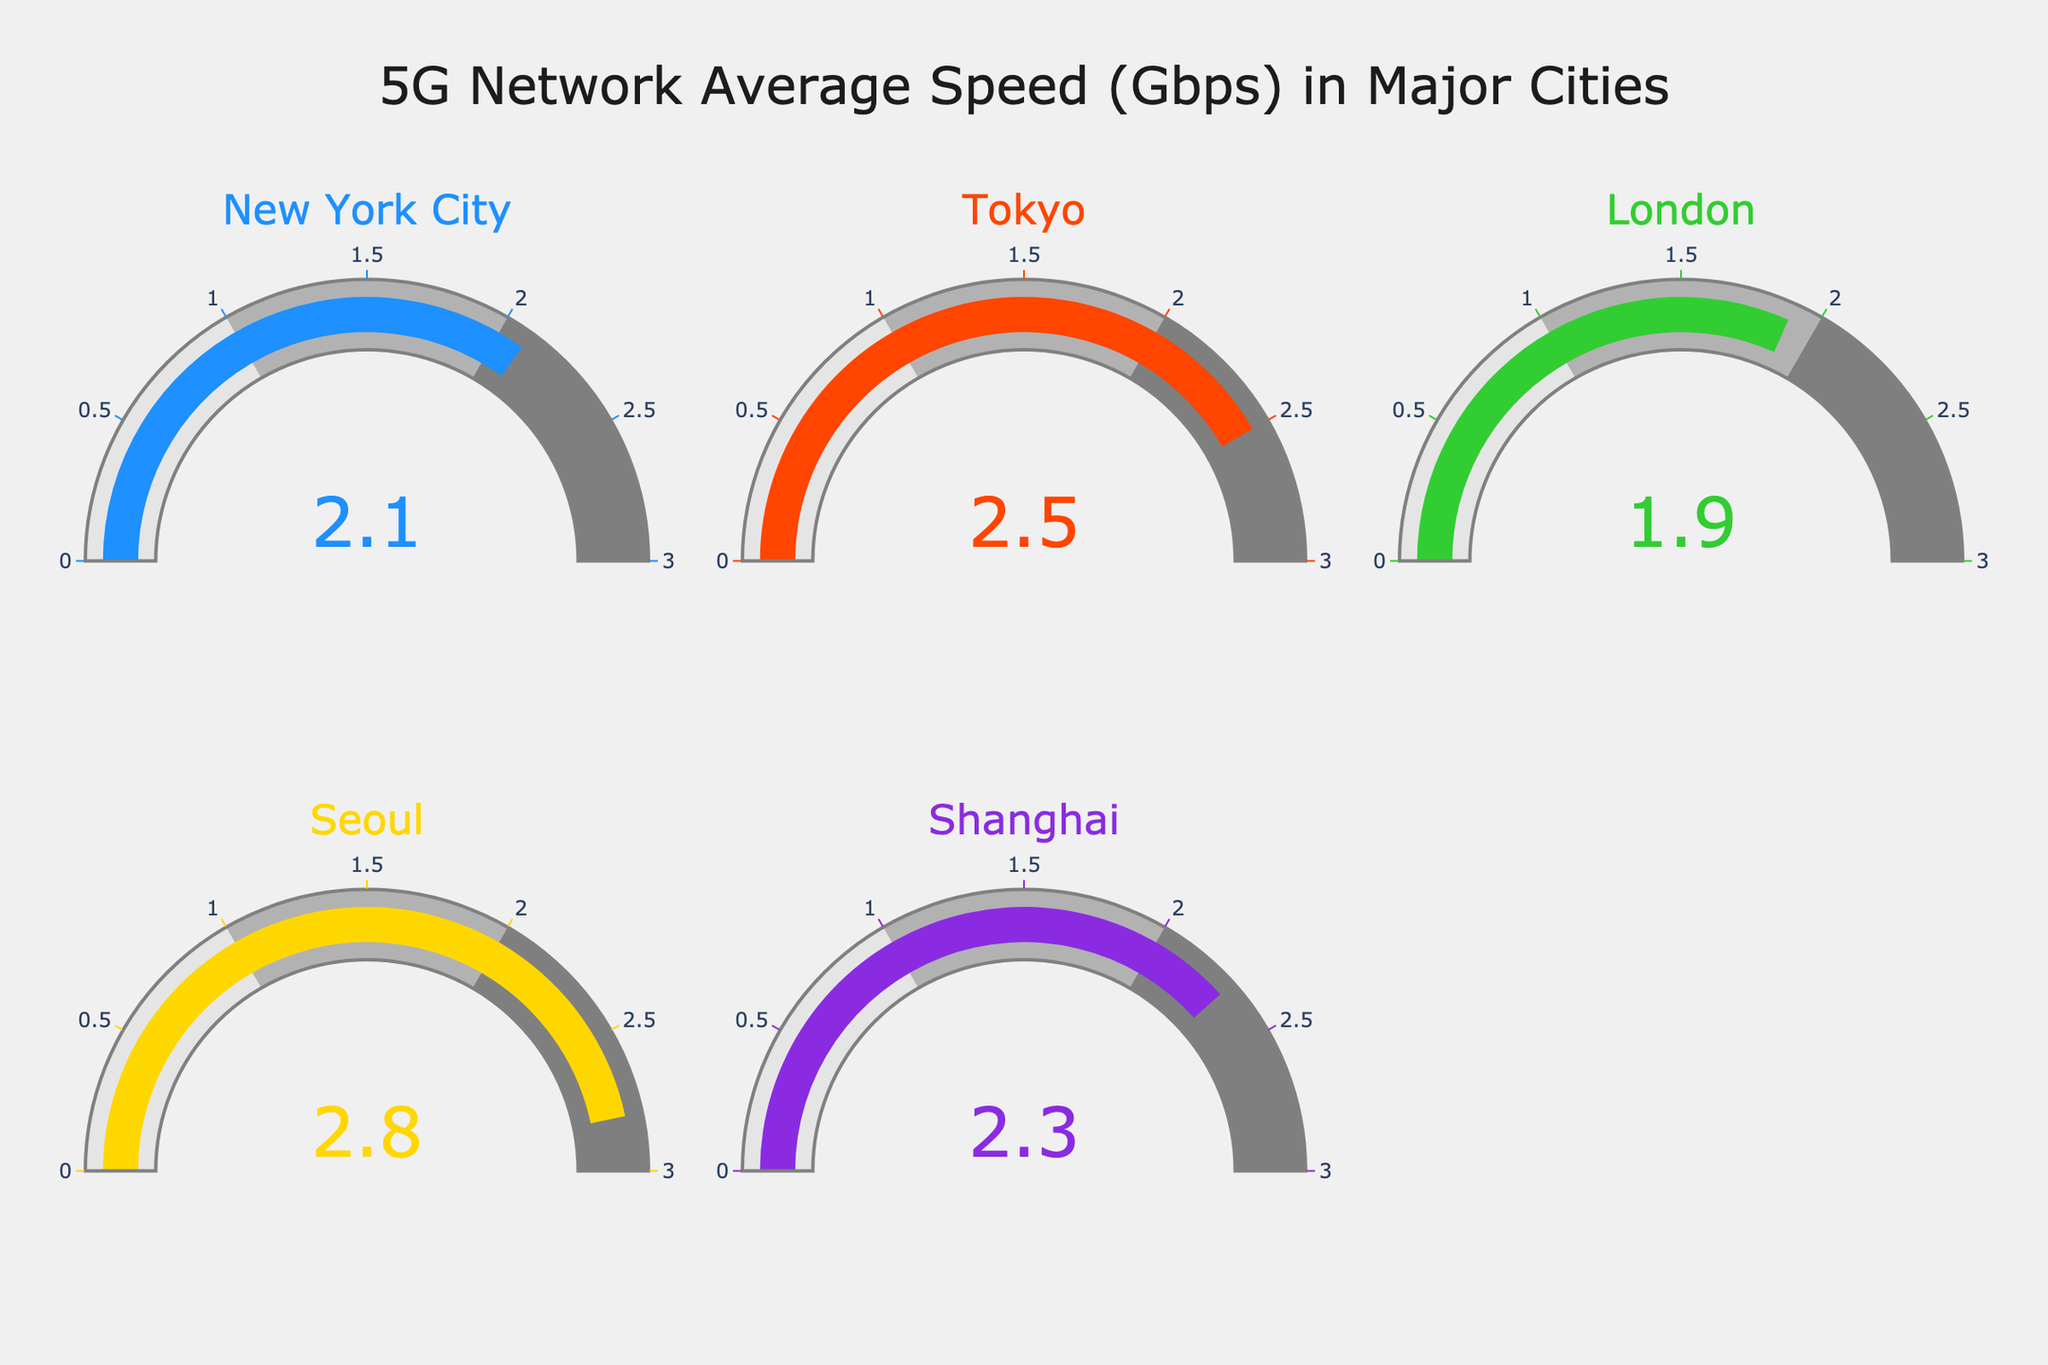which city has the highest average 5G network speed? By examining the gauge charts, we notice each city's average speed. Seoul has the highest speed of 2.8 Gbps.
Answer: Seoul which city has the lowest average 5G network speed? By comparing the gauge charts, we observe that London has the lowest speed at 1.9 Gbps.
Answer: London What is the range of average 5G network speeds displayed in the charts? The highest speed is 2.8 Gbps (Seoul) and the lowest is 1.9 Gbps (London). The range is 2.8 - 1.9 = 0.9 Gbps.
Answer: 0.9 Gbps What is the sum of average 5G network speeds of New York City and Tokyo? The average speed for New York City is 2.1 Gbps and for Tokyo is 2.5 Gbps. Adding them together: 2.1 + 2.5 = 4.6 Gbps
Answer: 4.6 Gbps How does the average 5G network speed of Shanghai compare to New York City? Looking at the gauge charts, Shanghai's speed is 2.3 Gbps and New York City's is 2.1 Gbps. Shanghai's speed is higher.
Answer: higher Which cities have an average 5G network speed greater than 2 Gbps? From the gauge charts, Tokyo (2.5 Gbps), Seoul (2.8 Gbps), and Shanghai (2.3 Gbps) have speeds greater than 2 Gbps.
Answer: Tokyo, Seoul, Shanghai What is the difference in average 5G network speed between Seoul and London? Seoul's speed is 2.8 Gbps and London's is 1.9 Gbps. The difference is 2.8 - 1.9 = 0.9 Gbps
Answer: 0.9 Gbps What is the average of the average 5G network speeds for all the cities? Adding the speeds: 2.1 + 2.5 + 1.9 + 2.8 + 2.3 = 11.6 Gbps. Dividing by 5 (number of cities), the average is 11.6 / 5 = 2.32 Gbps.
Answer: 2.32 Gbps 